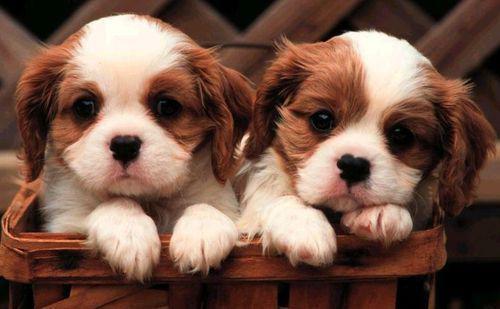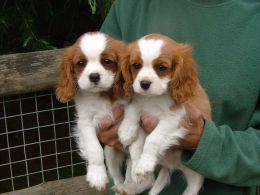The first image is the image on the left, the second image is the image on the right. Evaluate the accuracy of this statement regarding the images: "There are no more than two puppies.". Is it true? Answer yes or no. No. The first image is the image on the left, the second image is the image on the right. Analyze the images presented: Is the assertion "There are atleast 4 cute dogs total" valid? Answer yes or no. Yes. The first image is the image on the left, the second image is the image on the right. Evaluate the accuracy of this statement regarding the images: "One of the puppies is wearing a collar with pink heart.". Is it true? Answer yes or no. No. 